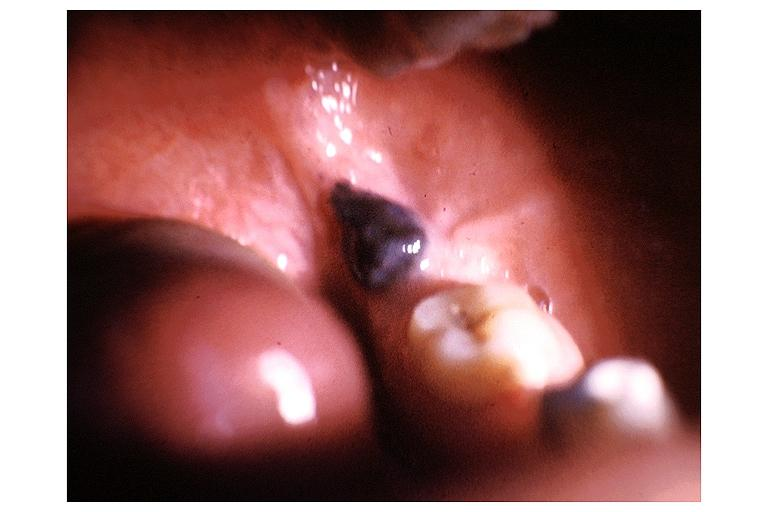does postpartum uterus show nevus?
Answer the question using a single word or phrase. No 